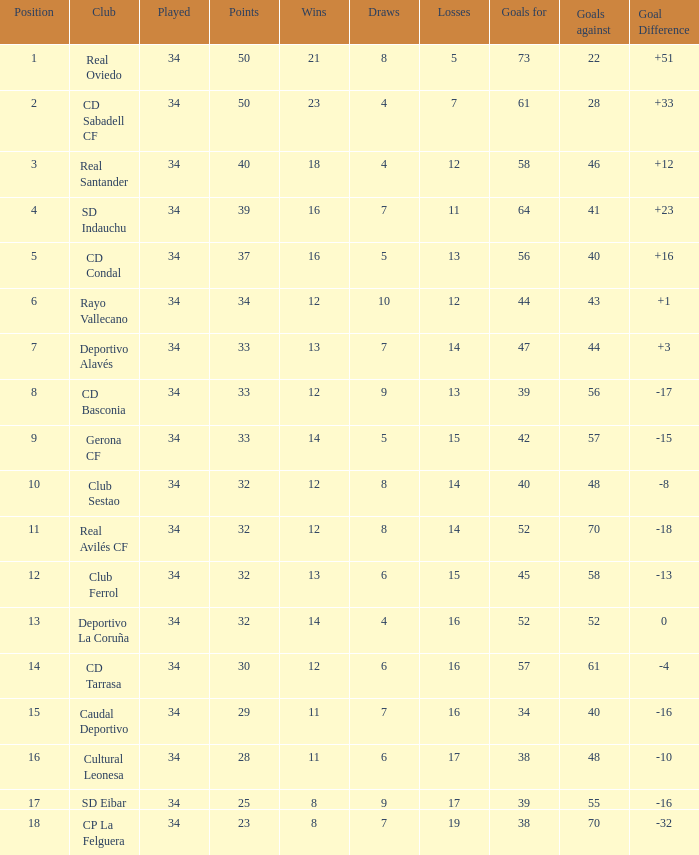What is the number of goals against teams that participated in more than 34 games? 0.0. 